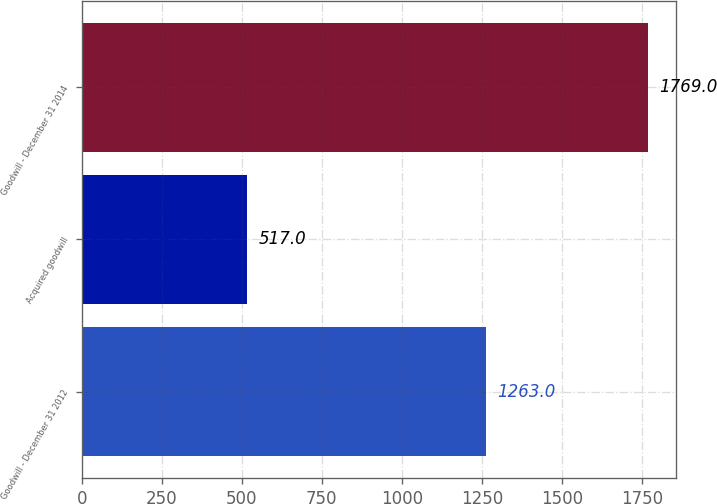<chart> <loc_0><loc_0><loc_500><loc_500><bar_chart><fcel>Goodwill - December 31 2012<fcel>Acquired goodwill<fcel>Goodwill - December 31 2014<nl><fcel>1263<fcel>517<fcel>1769<nl></chart> 